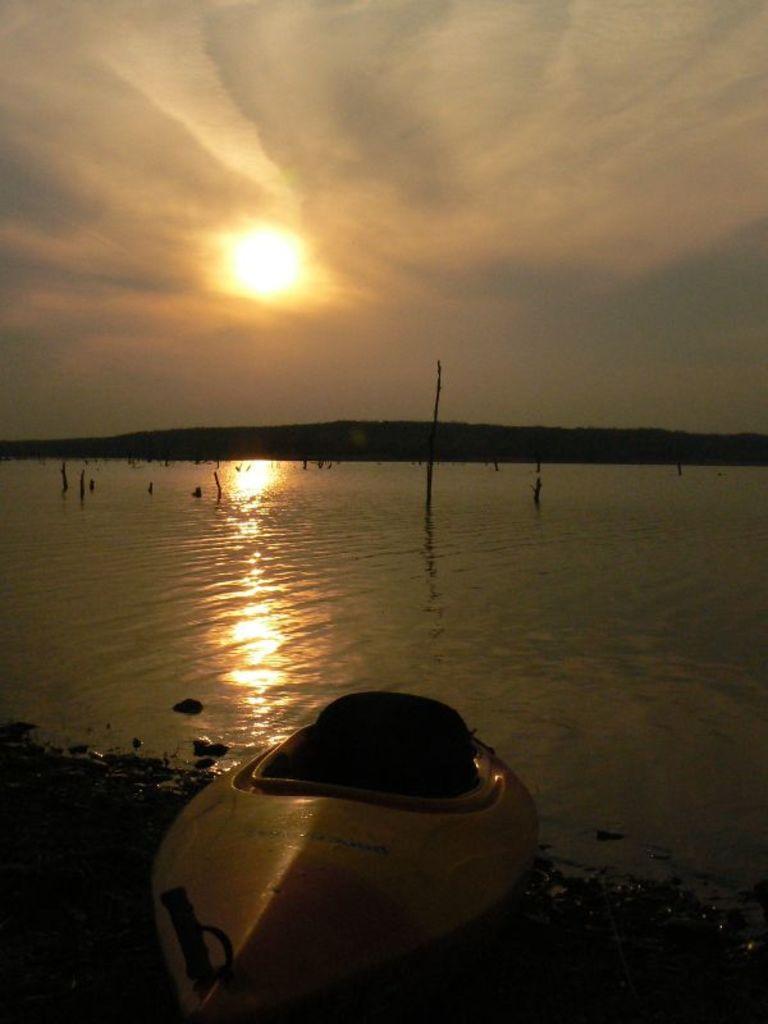Describe this image in one or two sentences. In this image in the foreground there is one boat, and in the center there is a beach in that beach there are some poles and in the background there are some mountains. At the top of the image there is sky. 